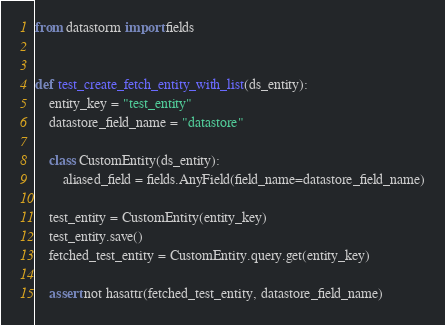Convert code to text. <code><loc_0><loc_0><loc_500><loc_500><_Python_>from datastorm import fields


def test_create_fetch_entity_with_list(ds_entity):
    entity_key = "test_entity"
    datastore_field_name = "datastore"

    class CustomEntity(ds_entity):
        aliased_field = fields.AnyField(field_name=datastore_field_name)

    test_entity = CustomEntity(entity_key)
    test_entity.save()
    fetched_test_entity = CustomEntity.query.get(entity_key)

    assert not hasattr(fetched_test_entity, datastore_field_name)
</code> 